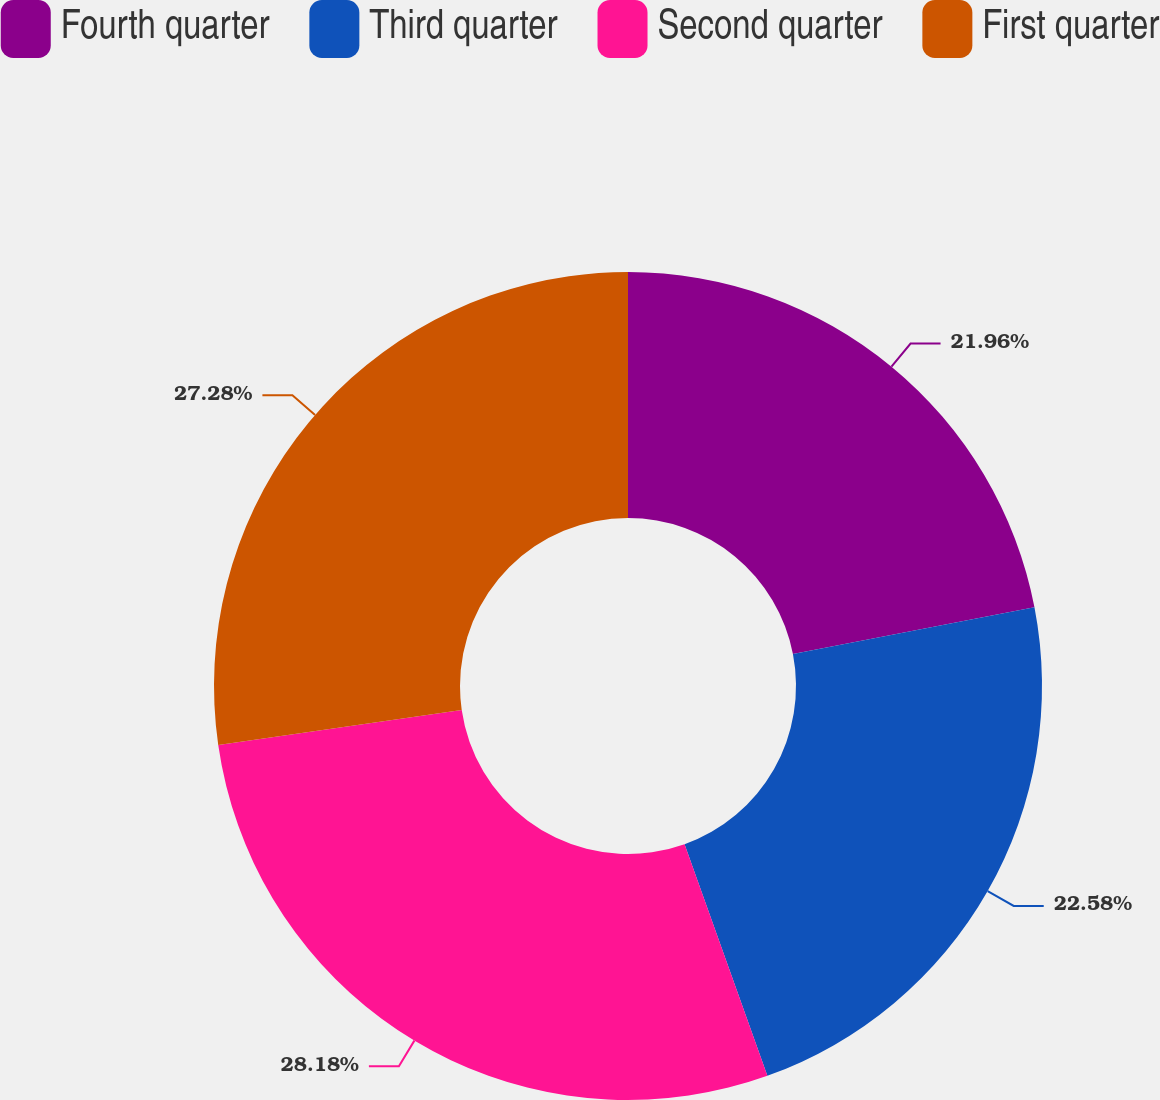<chart> <loc_0><loc_0><loc_500><loc_500><pie_chart><fcel>Fourth quarter<fcel>Third quarter<fcel>Second quarter<fcel>First quarter<nl><fcel>21.96%<fcel>22.58%<fcel>28.19%<fcel>27.28%<nl></chart> 